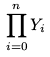<formula> <loc_0><loc_0><loc_500><loc_500>\prod _ { i = 0 } ^ { n } Y _ { i }</formula> 